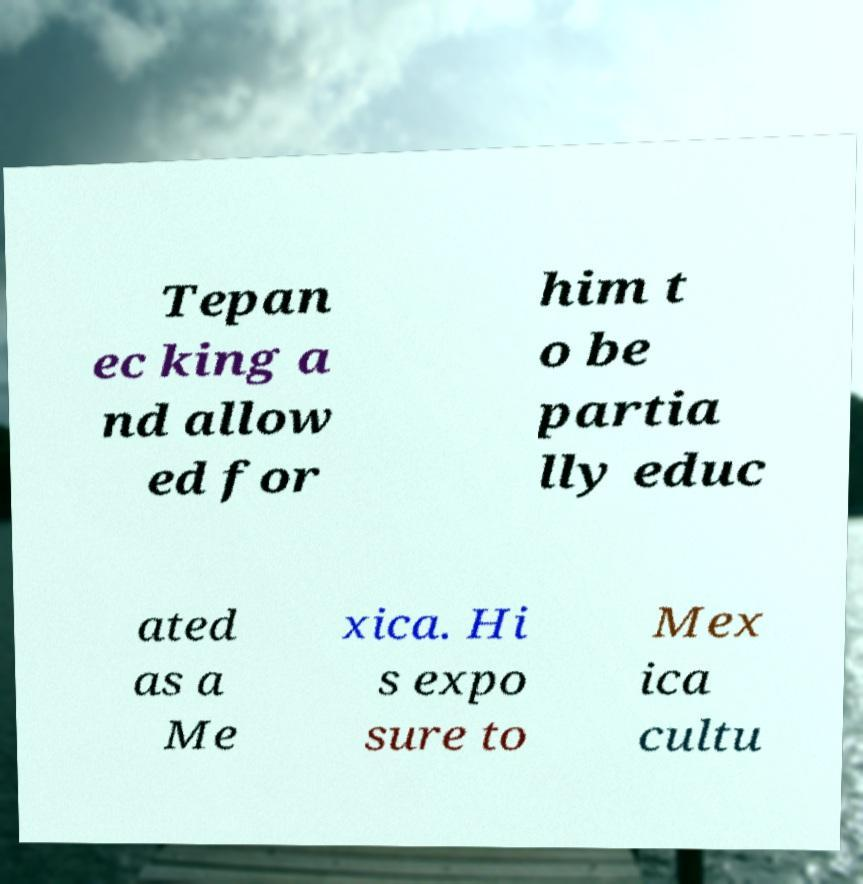Please read and relay the text visible in this image. What does it say? Tepan ec king a nd allow ed for him t o be partia lly educ ated as a Me xica. Hi s expo sure to Mex ica cultu 